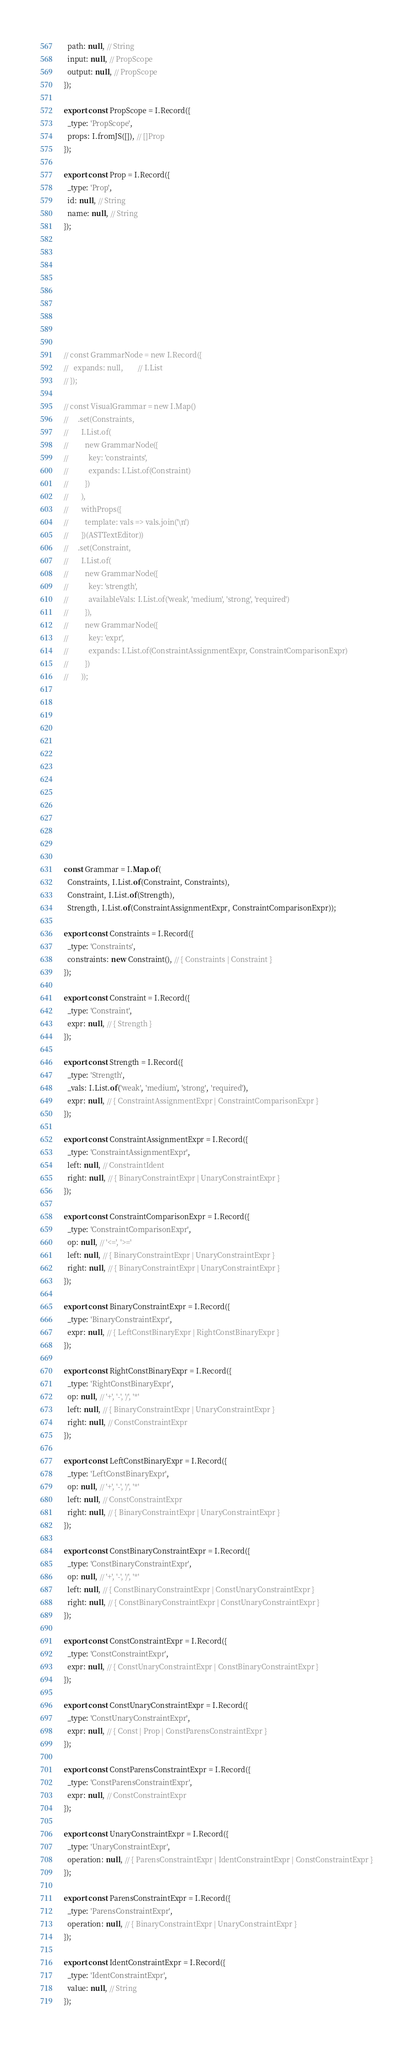<code> <loc_0><loc_0><loc_500><loc_500><_JavaScript_>  path: null, // String
  input: null, // PropScope
  output: null, // PropScope
});

export const PropScope = I.Record({
  _type: 'PropScope',
  props: I.fromJS([]), // []Prop
});

export const Prop = I.Record({
  _type: 'Prop',
  id: null, // String
  name: null, // String
});









// const GrammarNode = new I.Record({
//   expands: null,        // I.List
// });

// const VisualGrammar = new I.Map()
//     .set(Constraints,
//       I.List.of(
//         new GrammarNode({
//           key: 'constraints',
//           expands: I.List.of(Constraint)
//         })
//       ),
//       withProps({
//         template: vals => vals.join('\n')
//       })(ASTTextEditor))
//     .set(Constraint,
//       I.List.of(
//         new GrammarNode({
//           key: 'strength',
//           availableVals: I.List.of('weak', 'medium', 'strong', 'required')
//         }),
//         new GrammarNode({
//           key: 'expr',
//           expands: I.List.of(ConstraintAssignmentExpr, ConstraintComparisonExpr)
//         })
//       ));














const Grammar = I.Map.of(
  Constraints, I.List.of(Constraint, Constraints),
  Constraint, I.List.of(Strength),
  Strength, I.List.of(ConstraintAssignmentExpr, ConstraintComparisonExpr));

export const Constraints = I.Record({
  _type: 'Constraints',
  constraints: new Constraint(), // { Constraints | Constraint }
});

export const Constraint = I.Record({
  _type: 'Constraint',
  expr: null, // { Strength }
});

export const Strength = I.Record({
  _type: 'Strength',
  _vals: I.List.of('weak', 'medium', 'strong', 'required'),
  expr: null, // { ConstraintAssignmentExpr | ConstraintComparisonExpr }
});

export const ConstraintAssignmentExpr = I.Record({
  _type: 'ConstraintAssignmentExpr',
  left: null, // ConstraintIdent
  right: null, // { BinaryConstraintExpr | UnaryConstraintExpr }
});

export const ConstraintComparisonExpr = I.Record({
  _type: 'ConstraintComparisonExpr',
  op: null, // '<=', '>='
  left: null, // { BinaryConstraintExpr | UnaryConstraintExpr }
  right: null, // { BinaryConstraintExpr | UnaryConstraintExpr }
});

export const BinaryConstraintExpr = I.Record({
  _type: 'BinaryConstraintExpr',
  expr: null, // { LeftConstBinaryExpr | RightConstBinaryExpr }
});

export const RightConstBinaryExpr = I.Record({
  _type: 'RightConstBinaryExpr',
  op: null, // '+', '-', '/', '*'
  left: null, // { BinaryConstraintExpr | UnaryConstraintExpr }
  right: null, // ConstConstraintExpr
});

export const LeftConstBinaryExpr = I.Record({
  _type: 'LeftConstBinaryExpr',
  op: null, // '+', '-', '/', '*'
  left: null, // ConstConstraintExpr
  right: null, // { BinaryConstraintExpr | UnaryConstraintExpr }
});

export const ConstBinaryConstraintExpr = I.Record({
  _type: 'ConstBinaryConstraintExpr',
  op: null, // '+', '-', '/', '*'
  left: null, // { ConstBinaryConstraintExpr | ConstUnaryConstraintExpr }
  right: null, // { ConstBinaryConstraintExpr | ConstUnaryConstraintExpr }
});

export const ConstConstraintExpr = I.Record({
  _type: 'ConstConstraintExpr',
  expr: null, // { ConstUnaryConstraintExpr | ConstBinaryConstraintExpr }
});

export const ConstUnaryConstraintExpr = I.Record({
  _type: 'ConstUnaryConstraintExpr',
  expr: null, // { Const | Prop | ConstParensConstraintExpr }
});

export const ConstParensConstraintExpr = I.Record({
  _type: 'ConstParensConstraintExpr',
  expr: null, // ConstConstraintExpr
});

export const UnaryConstraintExpr = I.Record({
  _type: 'UnaryConstraintExpr',
  operation: null, // { ParensConstraintExpr | IdentConstraintExpr | ConstConstraintExpr }
});

export const ParensConstraintExpr = I.Record({
  _type: 'ParensConstraintExpr',
  operation: null, // { BinaryConstraintExpr | UnaryConstraintExpr }
});

export const IdentConstraintExpr = I.Record({
  _type: 'IdentConstraintExpr',
  value: null, // String
});
</code> 